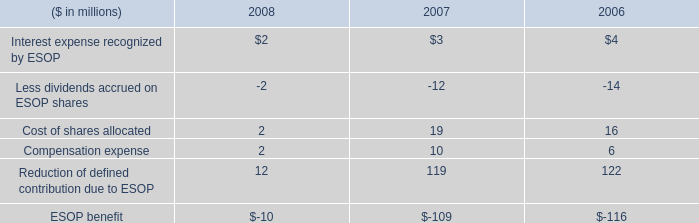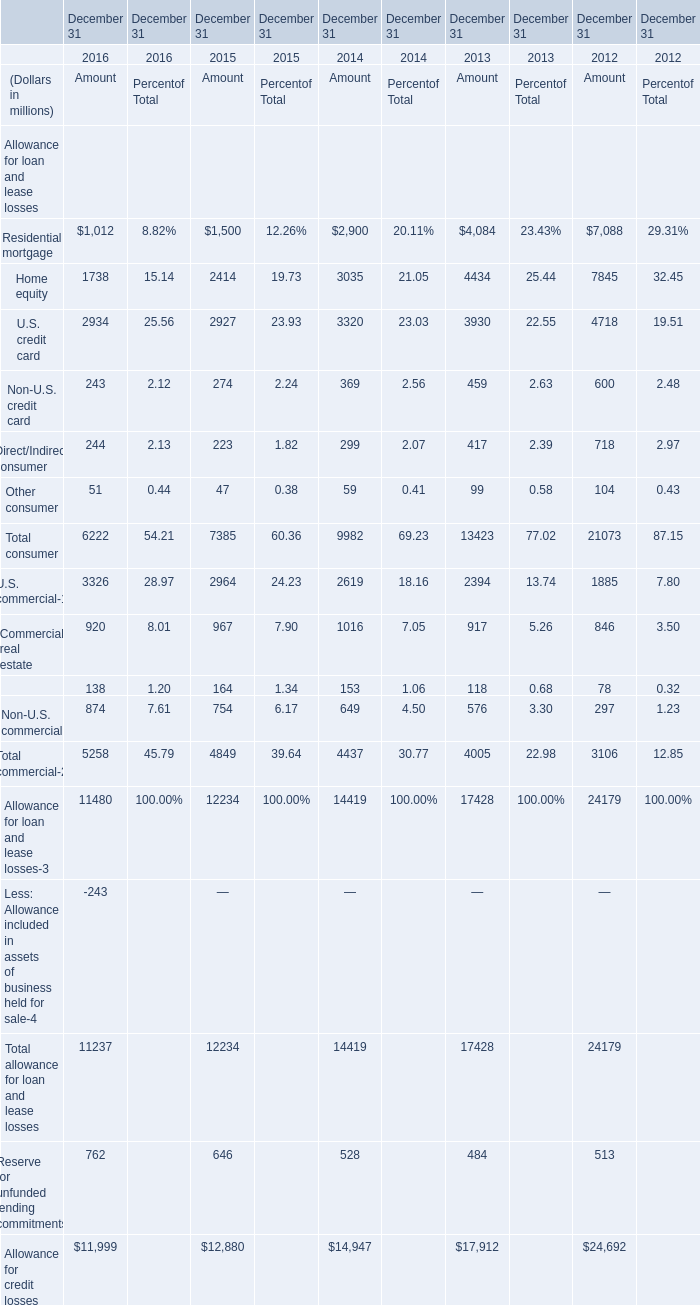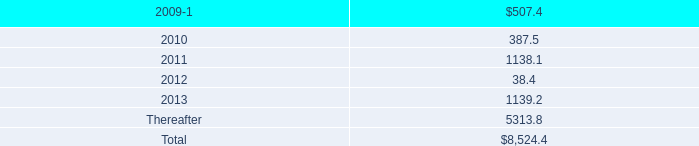What was the total amount of Residential mortgage for amount in 2016 and 2015 ? (in million) 
Computations: (1012 + 1500)
Answer: 2512.0. 